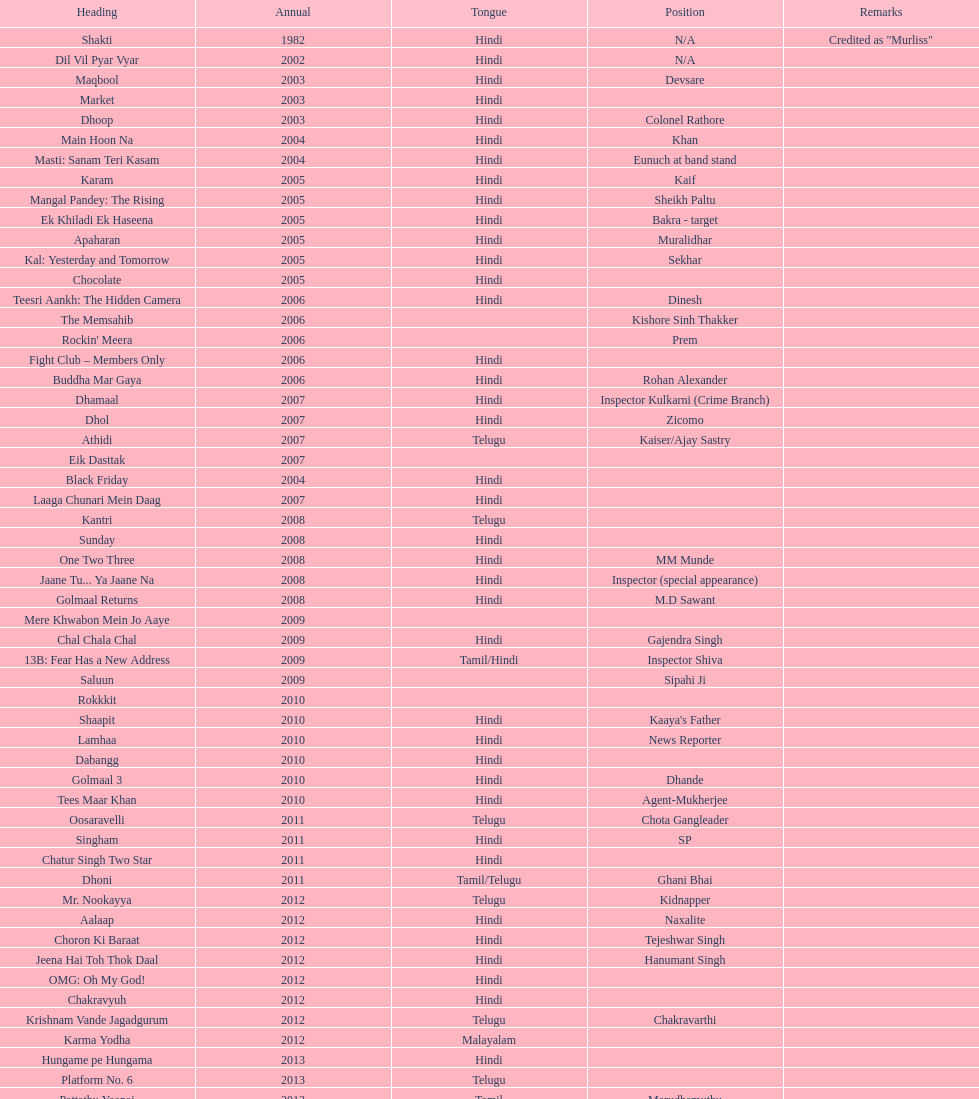Parse the table in full. {'header': ['Heading', 'Annual', 'Tongue', 'Position', 'Remarks'], 'rows': [['Shakti', '1982', 'Hindi', 'N/A', 'Credited as "Murliss"'], ['Dil Vil Pyar Vyar', '2002', 'Hindi', 'N/A', ''], ['Maqbool', '2003', 'Hindi', 'Devsare', ''], ['Market', '2003', 'Hindi', '', ''], ['Dhoop', '2003', 'Hindi', 'Colonel Rathore', ''], ['Main Hoon Na', '2004', 'Hindi', 'Khan', ''], ['Masti: Sanam Teri Kasam', '2004', 'Hindi', 'Eunuch at band stand', ''], ['Karam', '2005', 'Hindi', 'Kaif', ''], ['Mangal Pandey: The Rising', '2005', 'Hindi', 'Sheikh Paltu', ''], ['Ek Khiladi Ek Haseena', '2005', 'Hindi', 'Bakra - target', ''], ['Apaharan', '2005', 'Hindi', 'Muralidhar', ''], ['Kal: Yesterday and Tomorrow', '2005', 'Hindi', 'Sekhar', ''], ['Chocolate', '2005', 'Hindi', '', ''], ['Teesri Aankh: The Hidden Camera', '2006', 'Hindi', 'Dinesh', ''], ['The Memsahib', '2006', '', 'Kishore Sinh Thakker', ''], ["Rockin' Meera", '2006', '', 'Prem', ''], ['Fight Club – Members Only', '2006', 'Hindi', '', ''], ['Buddha Mar Gaya', '2006', 'Hindi', 'Rohan Alexander', ''], ['Dhamaal', '2007', 'Hindi', 'Inspector Kulkarni (Crime Branch)', ''], ['Dhol', '2007', 'Hindi', 'Zicomo', ''], ['Athidi', '2007', 'Telugu', 'Kaiser/Ajay Sastry', ''], ['Eik Dasttak', '2007', '', '', ''], ['Black Friday', '2004', 'Hindi', '', ''], ['Laaga Chunari Mein Daag', '2007', 'Hindi', '', ''], ['Kantri', '2008', 'Telugu', '', ''], ['Sunday', '2008', 'Hindi', '', ''], ['One Two Three', '2008', 'Hindi', 'MM Munde', ''], ['Jaane Tu... Ya Jaane Na', '2008', 'Hindi', 'Inspector (special appearance)', ''], ['Golmaal Returns', '2008', 'Hindi', 'M.D Sawant', ''], ['Mere Khwabon Mein Jo Aaye', '2009', '', '', ''], ['Chal Chala Chal', '2009', 'Hindi', 'Gajendra Singh', ''], ['13B: Fear Has a New Address', '2009', 'Tamil/Hindi', 'Inspector Shiva', ''], ['Saluun', '2009', '', 'Sipahi Ji', ''], ['Rokkkit', '2010', '', '', ''], ['Shaapit', '2010', 'Hindi', "Kaaya's Father", ''], ['Lamhaa', '2010', 'Hindi', 'News Reporter', ''], ['Dabangg', '2010', 'Hindi', '', ''], ['Golmaal 3', '2010', 'Hindi', 'Dhande', ''], ['Tees Maar Khan', '2010', 'Hindi', 'Agent-Mukherjee', ''], ['Oosaravelli', '2011', 'Telugu', 'Chota Gangleader', ''], ['Singham', '2011', 'Hindi', 'SP', ''], ['Chatur Singh Two Star', '2011', 'Hindi', '', ''], ['Dhoni', '2011', 'Tamil/Telugu', 'Ghani Bhai', ''], ['Mr. Nookayya', '2012', 'Telugu', 'Kidnapper', ''], ['Aalaap', '2012', 'Hindi', 'Naxalite', ''], ['Choron Ki Baraat', '2012', 'Hindi', 'Tejeshwar Singh', ''], ['Jeena Hai Toh Thok Daal', '2012', 'Hindi', 'Hanumant Singh', ''], ['OMG: Oh My God!', '2012', 'Hindi', '', ''], ['Chakravyuh', '2012', 'Hindi', '', ''], ['Krishnam Vande Jagadgurum', '2012', 'Telugu', 'Chakravarthi', ''], ['Karma Yodha', '2012', 'Malayalam', '', ''], ['Hungame pe Hungama', '2013', 'Hindi', '', ''], ['Platform No. 6', '2013', 'Telugu', '', ''], ['Pattathu Yaanai', '2013', 'Tamil', 'Marudhamuthu', ''], ['Zindagi 50-50', '2013', 'Hindi', '', ''], ['Yevadu', '2013', 'Telugu', 'Durani', ''], ['Karmachari', '2013', 'Telugu', '', '']]} What is the most recent malayalam movie featuring this actor? Karma Yodha. 